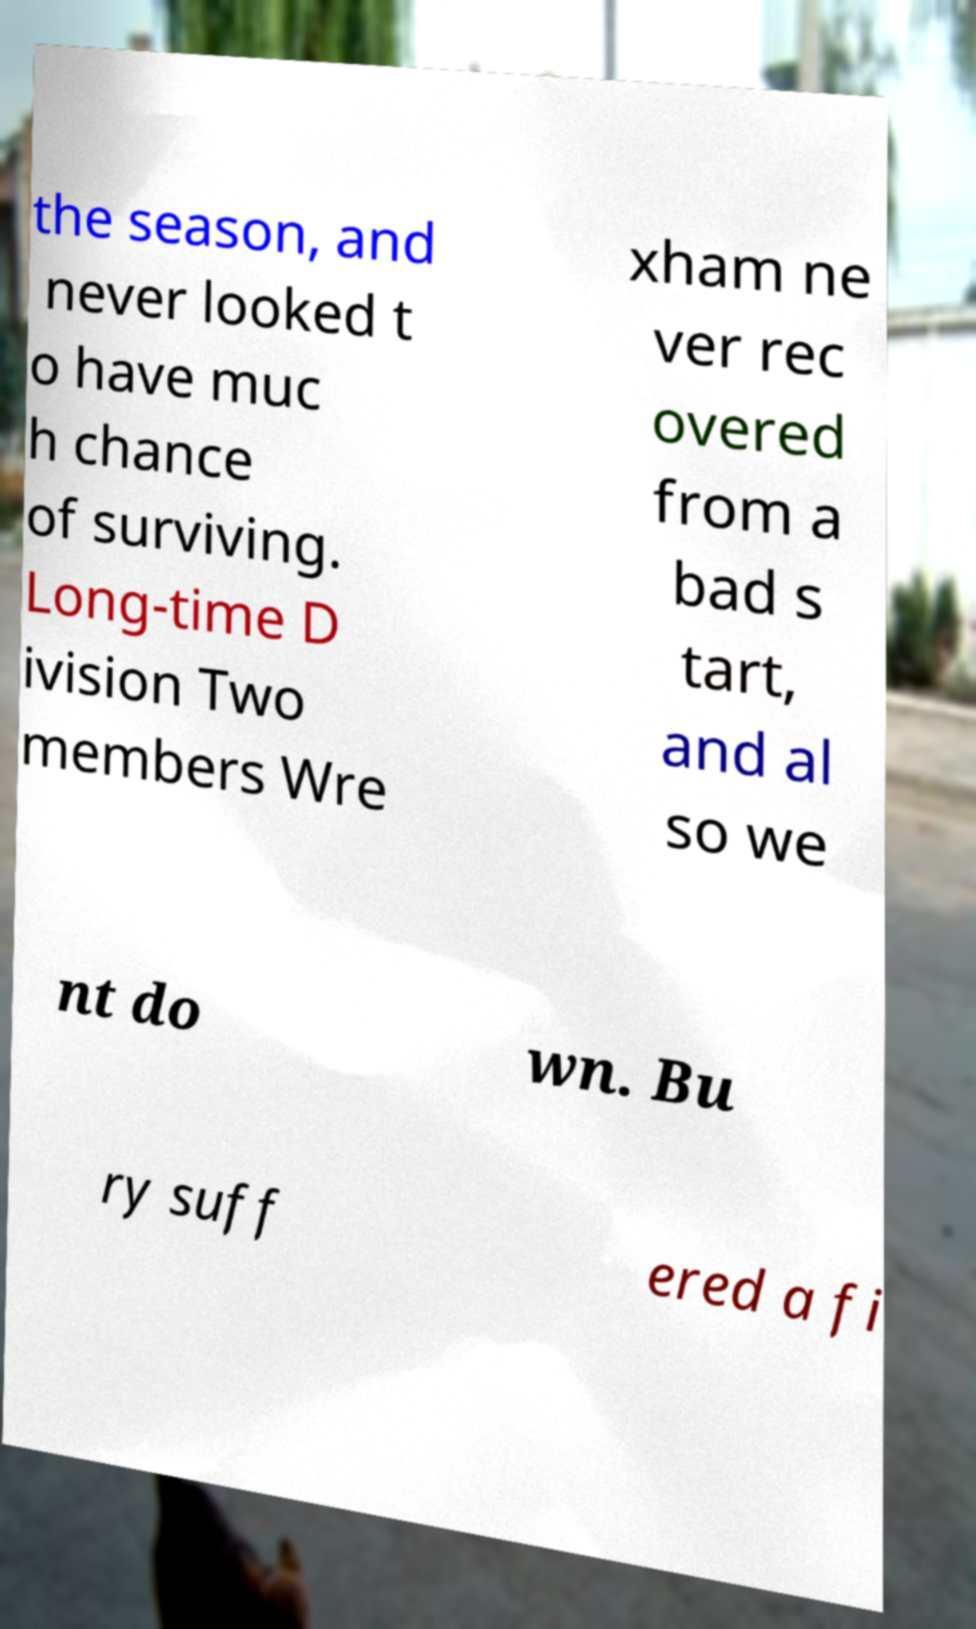Can you accurately transcribe the text from the provided image for me? the season, and never looked t o have muc h chance of surviving. Long-time D ivision Two members Wre xham ne ver rec overed from a bad s tart, and al so we nt do wn. Bu ry suff ered a fi 